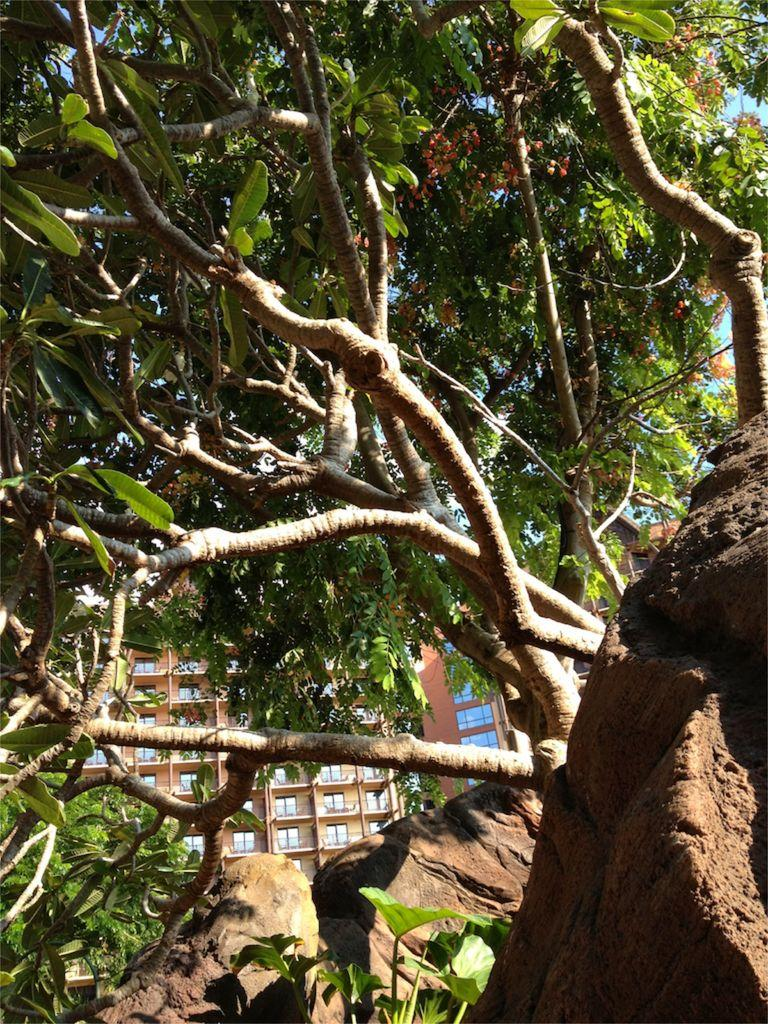What type of natural elements can be seen in the image? There are trees in the image. What type of man-made structures are present in the image? There are buildings in the image. What type of terrain is visible at the bottom of the image? There are rocks at the bottom of the image. What type of skin condition can be seen on the trees in the image? There is no mention of any skin condition on the trees in the image. The trees appear to be healthy and normal. 